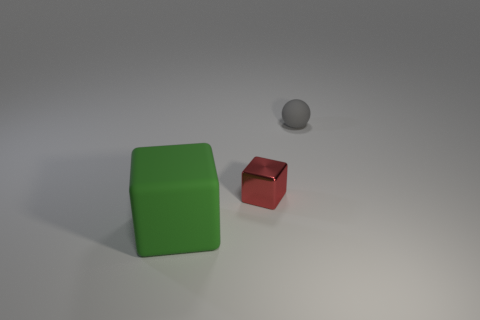Add 2 gray cylinders. How many objects exist? 5 Subtract all spheres. How many objects are left? 2 Subtract 0 yellow cylinders. How many objects are left? 3 Subtract all large gray metallic blocks. Subtract all tiny gray rubber things. How many objects are left? 2 Add 3 spheres. How many spheres are left? 4 Add 2 large green blocks. How many large green blocks exist? 3 